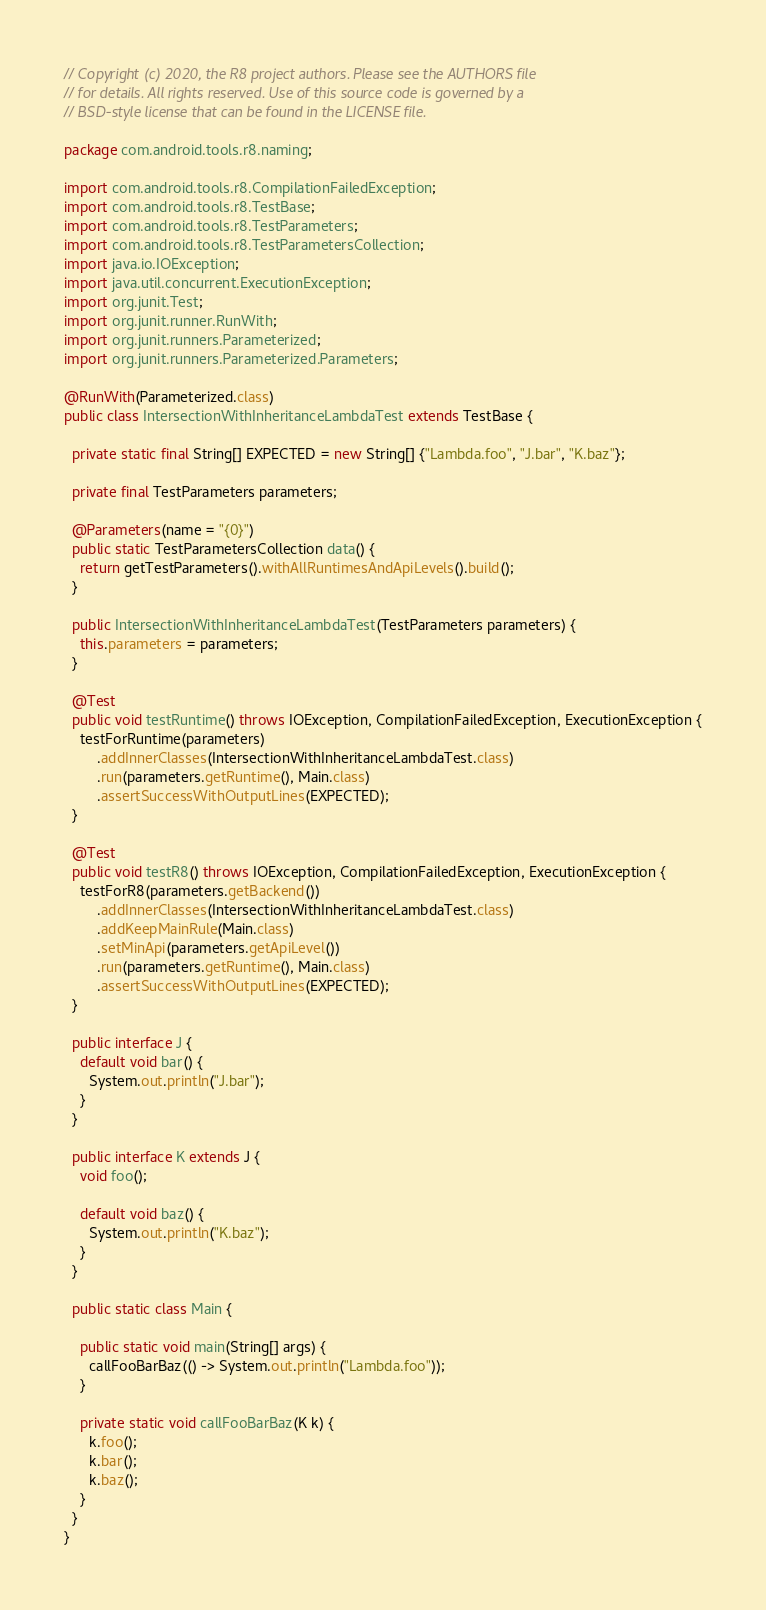Convert code to text. <code><loc_0><loc_0><loc_500><loc_500><_Java_>// Copyright (c) 2020, the R8 project authors. Please see the AUTHORS file
// for details. All rights reserved. Use of this source code is governed by a
// BSD-style license that can be found in the LICENSE file.

package com.android.tools.r8.naming;

import com.android.tools.r8.CompilationFailedException;
import com.android.tools.r8.TestBase;
import com.android.tools.r8.TestParameters;
import com.android.tools.r8.TestParametersCollection;
import java.io.IOException;
import java.util.concurrent.ExecutionException;
import org.junit.Test;
import org.junit.runner.RunWith;
import org.junit.runners.Parameterized;
import org.junit.runners.Parameterized.Parameters;

@RunWith(Parameterized.class)
public class IntersectionWithInheritanceLambdaTest extends TestBase {

  private static final String[] EXPECTED = new String[] {"Lambda.foo", "J.bar", "K.baz"};

  private final TestParameters parameters;

  @Parameters(name = "{0}")
  public static TestParametersCollection data() {
    return getTestParameters().withAllRuntimesAndApiLevels().build();
  }

  public IntersectionWithInheritanceLambdaTest(TestParameters parameters) {
    this.parameters = parameters;
  }

  @Test
  public void testRuntime() throws IOException, CompilationFailedException, ExecutionException {
    testForRuntime(parameters)
        .addInnerClasses(IntersectionWithInheritanceLambdaTest.class)
        .run(parameters.getRuntime(), Main.class)
        .assertSuccessWithOutputLines(EXPECTED);
  }

  @Test
  public void testR8() throws IOException, CompilationFailedException, ExecutionException {
    testForR8(parameters.getBackend())
        .addInnerClasses(IntersectionWithInheritanceLambdaTest.class)
        .addKeepMainRule(Main.class)
        .setMinApi(parameters.getApiLevel())
        .run(parameters.getRuntime(), Main.class)
        .assertSuccessWithOutputLines(EXPECTED);
  }

  public interface J {
    default void bar() {
      System.out.println("J.bar");
    }
  }

  public interface K extends J {
    void foo();

    default void baz() {
      System.out.println("K.baz");
    }
  }

  public static class Main {

    public static void main(String[] args) {
      callFooBarBaz(() -> System.out.println("Lambda.foo"));
    }

    private static void callFooBarBaz(K k) {
      k.foo();
      k.bar();
      k.baz();
    }
  }
}
</code> 